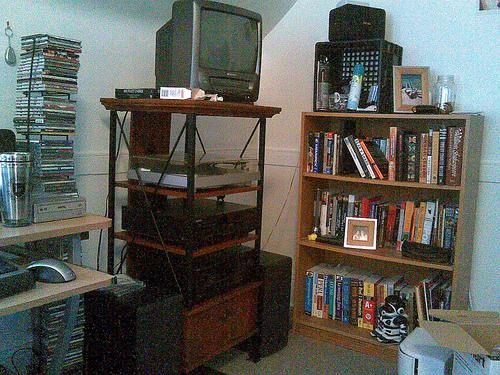Question: what is on the shelf right below the television?
Choices:
A. Stereo.
B. DVD player.
C. Wii console.
D. A record player.
Answer with the letter. Answer: D Question: what is hanging on the wall next to the CD rack?
Choices:
A. Photo.
B. Painting.
C. A keychain.
D. Curtain.
Answer with the letter. Answer: C 